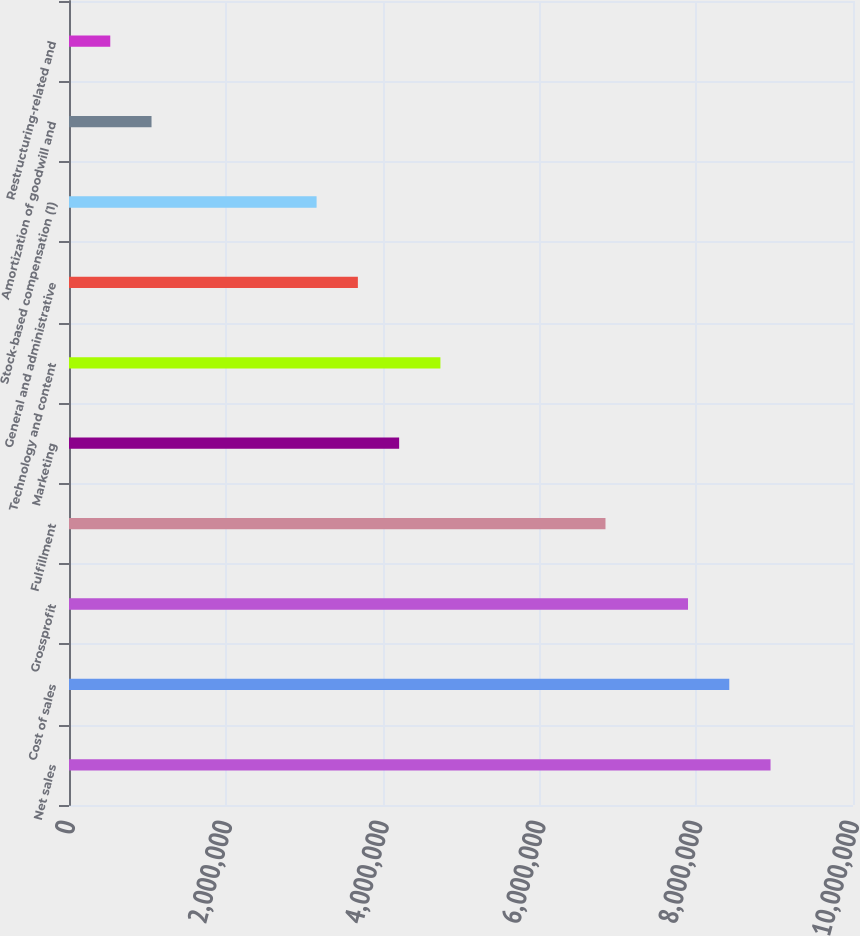Convert chart. <chart><loc_0><loc_0><loc_500><loc_500><bar_chart><fcel>Net sales<fcel>Cost of sales<fcel>Grossprofit<fcel>Fulfillment<fcel>Marketing<fcel>Technology and content<fcel>General and administrative<fcel>Stock-based compensation (1)<fcel>Amortization of goodwill and<fcel>Restructuring-related and<nl><fcel>8.94829e+06<fcel>8.42192e+06<fcel>7.89555e+06<fcel>6.84281e+06<fcel>4.21096e+06<fcel>4.73733e+06<fcel>3.68459e+06<fcel>3.15822e+06<fcel>1.05274e+06<fcel>526370<nl></chart> 